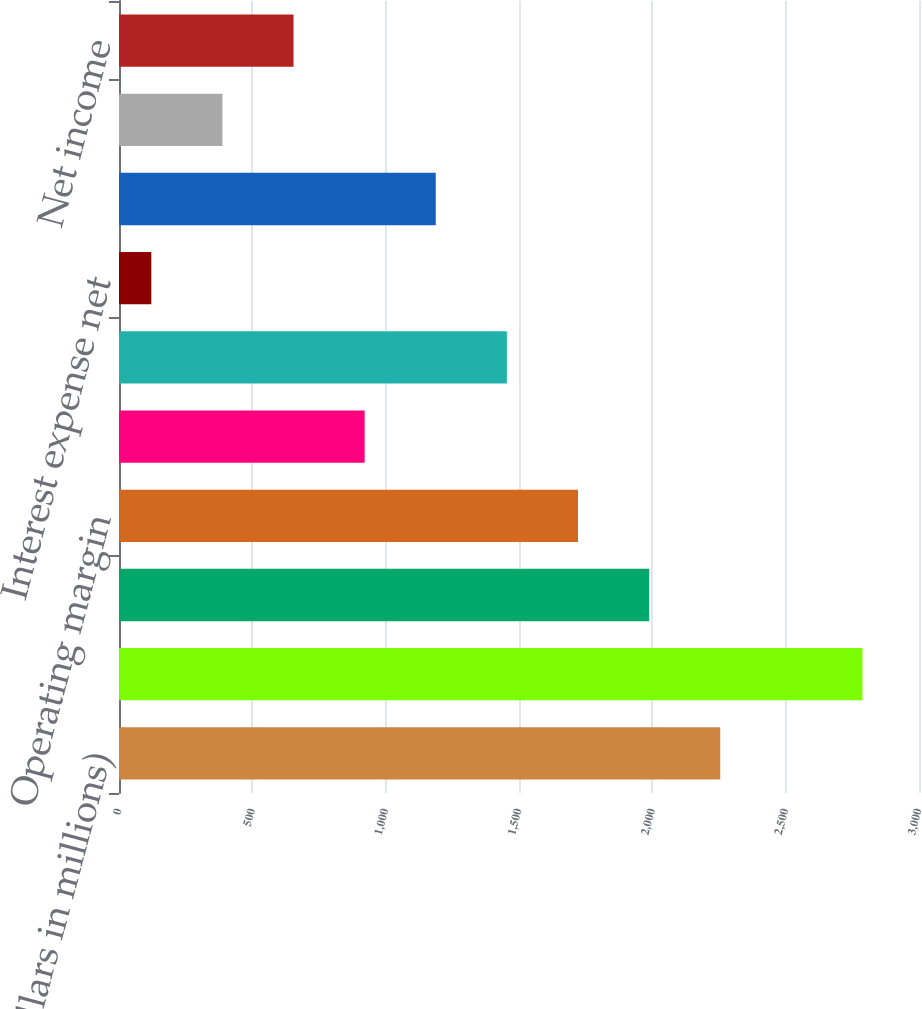Convert chart to OTSL. <chart><loc_0><loc_0><loc_500><loc_500><bar_chart><fcel>(dollars in millions)<fcel>Total revenues<fcel>Cost of sales<fcel>Operating margin<fcel>General and administrative<fcel>Income from operations<fcel>Interest expense net<fcel>Income before provision for<fcel>Provision for income taxes<fcel>Net income<nl><fcel>2254.62<fcel>2788<fcel>1987.93<fcel>1721.24<fcel>921.17<fcel>1454.55<fcel>121.1<fcel>1187.86<fcel>387.79<fcel>654.48<nl></chart> 